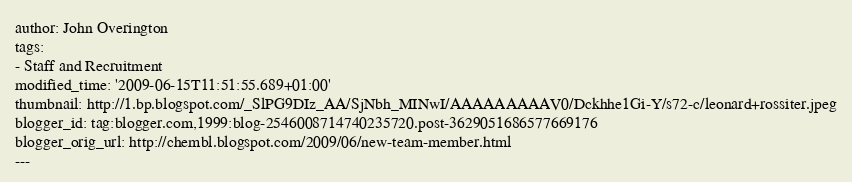<code> <loc_0><loc_0><loc_500><loc_500><_HTML_>author: John Overington
tags:
- Staff and Recruitment
modified_time: '2009-06-15T11:51:55.689+01:00'
thumbnail: http://1.bp.blogspot.com/_SlPG9DIz_AA/SjNbh_MINwI/AAAAAAAAAV0/Dckhhe1Gi-Y/s72-c/leonard+rossiter.jpeg
blogger_id: tag:blogger.com,1999:blog-2546008714740235720.post-3629051686577669176
blogger_orig_url: http://chembl.blogspot.com/2009/06/new-team-member.html
---
</code> 